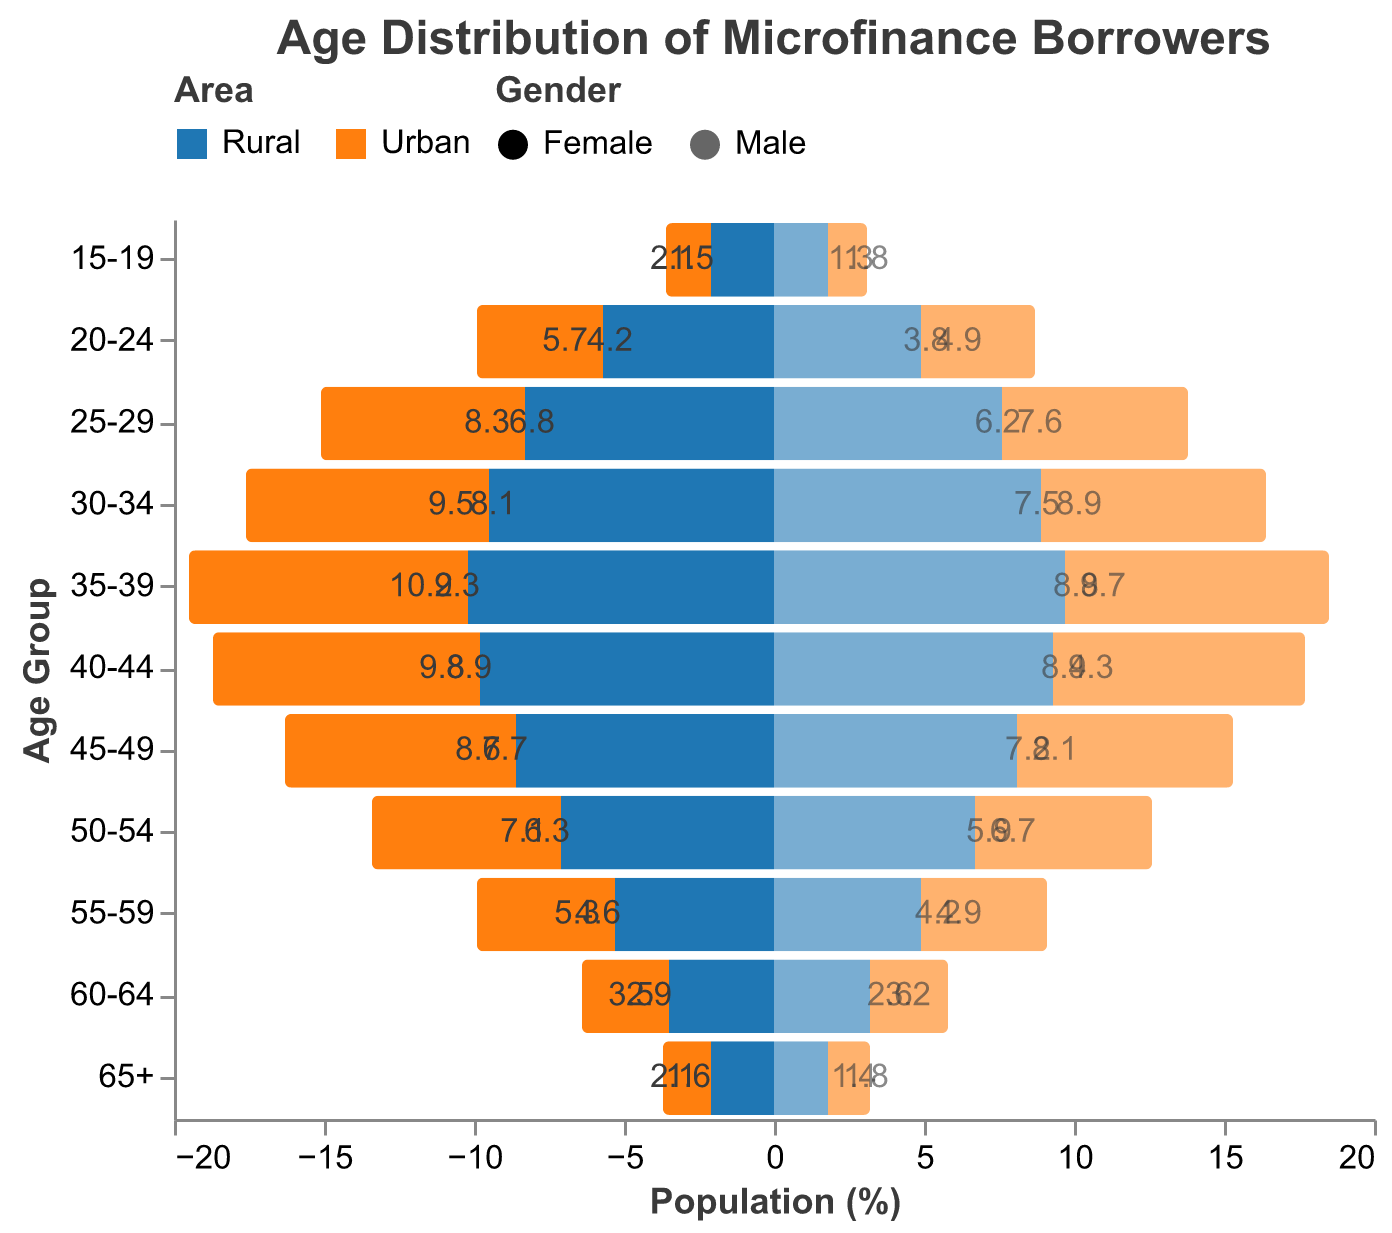What is the title of the plot? The title of the plot is prominently displayed at the top. It reads "Age Distribution of Microfinance Borrowers."
Answer: Age Distribution of Microfinance Borrowers Which age group has the highest percentage of rural male borrowers? The highest percentage for rural male borrowers can be observed by identifying the age group with the longest bar in the rural male category. It's the 35-39 age group.
Answer: 35-39 How does the percentage of rural female borrowers in the 30-34 age group compare to urban female borrowers in the same age group? Look at the bars representing the 30-34 age group for rural and urban females. The rural female percentage is 9.5%, while the urban female percentage is 8.1%.
Answer: Rural is higher by 1.4% What is the trend in the percentage of borrowers as age increases from 15-19 to 65+ in rural areas? The trend can be observed by following the bars from age group 15-19 to 65+ for rural areas. Both rural males and females show a decrease in percentage as age increases.
Answer: Decreasing trend What percentage of urban male borrowers belong to the 45-49 age group? The percentage of urban male borrowers in the 45-49 age group can be read directly from the bar representing urban males in that age group.
Answer: 7.2% Which age group has the smallest difference in percentage between rural and urban female borrowers? For each age group, subtract the urban female percentage from the rural female percentage and find the minimum difference. The smallest difference is in the 65+ age group, where the difference is 0.5% (2.1% - 1.6%).
Answer: 65+ Compare the percentage of rural male and urban male borrowers in the 25-29 age group. The percentages for rural male and urban male borrowers in the 25-29 age group are 7.6% and 6.2%, respectively.
Answer: Rural males are higher by 1.4% How does the percentage of urban female borrowers in the age group 40-44 compare to the percentage of rural female borrowers in the age group 20-24? The urban female percentage in the 40-44 age group (8.9%) is compared to the rural female percentage in the 20-24 age group (5.7%).
Answer: Urban females in 40-44 are higher by 3.2% What is the gender distribution among rural borrowers in the 35-39 age group? Observing the bars for rural female and male borrowers in the 35-39 age group, females account for 10.2% and males for 9.7%.
Answer: Females: 10.2%, Males: 9.7% Identify the age group with the highest overall percentage of borrowers, regardless of gender and area. Add the percentages of all categories (rural female, rural male, urban female, urban male) for each age group. The age group with the highest sum is 35-39 (10.2 + 9.7 + 9.3 + 8.8 = 38.0%).
Answer: 35-39 